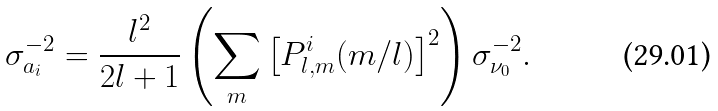Convert formula to latex. <formula><loc_0><loc_0><loc_500><loc_500>\sigma _ { a _ { i } } ^ { - 2 } = \frac { l ^ { 2 } } { 2 l + 1 } \left ( \sum _ { m } \left [ P _ { l , m } ^ { i } ( m / l ) \right ] ^ { 2 } \right ) \sigma ^ { - 2 } _ { \nu _ { 0 } } .</formula> 